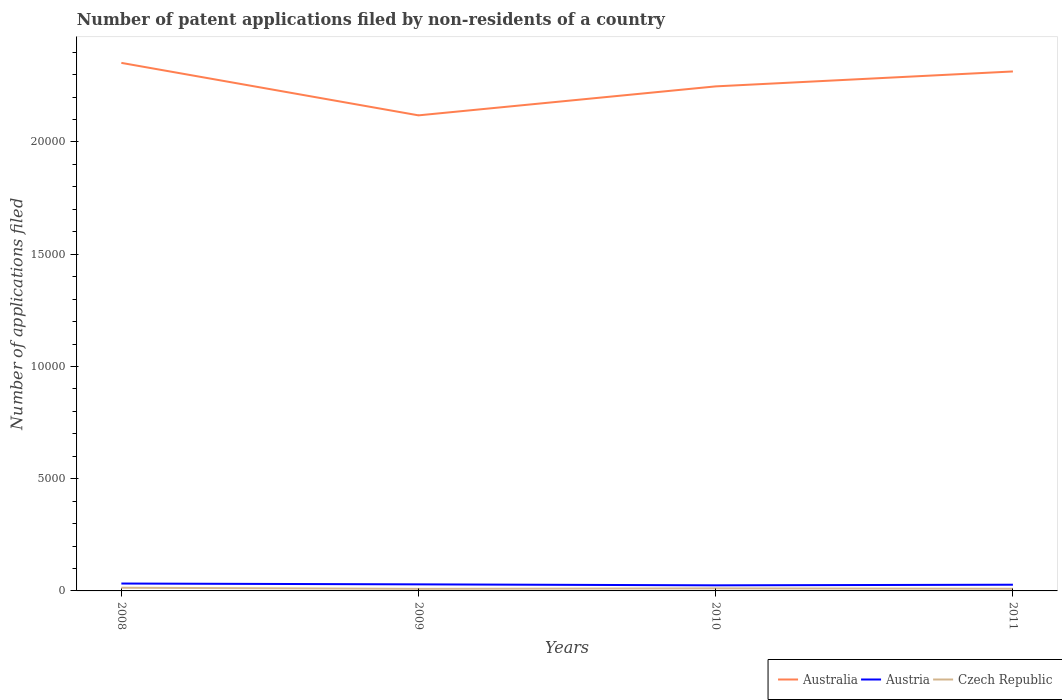How many different coloured lines are there?
Provide a short and direct response. 3. Is the number of lines equal to the number of legend labels?
Ensure brevity in your answer.  Yes. Across all years, what is the maximum number of applications filed in Australia?
Give a very brief answer. 2.12e+04. What is the total number of applications filed in Australia in the graph?
Provide a succinct answer. -665. What is the difference between the highest and the second highest number of applications filed in Czech Republic?
Give a very brief answer. 50. Are the values on the major ticks of Y-axis written in scientific E-notation?
Your answer should be compact. No. Does the graph contain grids?
Give a very brief answer. No. How many legend labels are there?
Keep it short and to the point. 3. What is the title of the graph?
Make the answer very short. Number of patent applications filed by non-residents of a country. Does "Switzerland" appear as one of the legend labels in the graph?
Keep it short and to the point. No. What is the label or title of the X-axis?
Make the answer very short. Years. What is the label or title of the Y-axis?
Provide a succinct answer. Number of applications filed. What is the Number of applications filed of Australia in 2008?
Provide a succinct answer. 2.35e+04. What is the Number of applications filed in Austria in 2008?
Provide a short and direct response. 329. What is the Number of applications filed in Czech Republic in 2008?
Ensure brevity in your answer.  142. What is the Number of applications filed of Australia in 2009?
Give a very brief answer. 2.12e+04. What is the Number of applications filed in Austria in 2009?
Offer a very short reply. 292. What is the Number of applications filed of Czech Republic in 2009?
Give a very brief answer. 92. What is the Number of applications filed of Australia in 2010?
Your answer should be very brief. 2.25e+04. What is the Number of applications filed of Austria in 2010?
Offer a terse response. 249. What is the Number of applications filed of Czech Republic in 2010?
Your answer should be very brief. 114. What is the Number of applications filed of Australia in 2011?
Provide a succinct answer. 2.31e+04. What is the Number of applications filed in Austria in 2011?
Provide a short and direct response. 276. What is the Number of applications filed in Czech Republic in 2011?
Provide a succinct answer. 97. Across all years, what is the maximum Number of applications filed of Australia?
Keep it short and to the point. 2.35e+04. Across all years, what is the maximum Number of applications filed of Austria?
Ensure brevity in your answer.  329. Across all years, what is the maximum Number of applications filed of Czech Republic?
Your response must be concise. 142. Across all years, what is the minimum Number of applications filed of Australia?
Make the answer very short. 2.12e+04. Across all years, what is the minimum Number of applications filed of Austria?
Provide a succinct answer. 249. Across all years, what is the minimum Number of applications filed of Czech Republic?
Ensure brevity in your answer.  92. What is the total Number of applications filed of Australia in the graph?
Keep it short and to the point. 9.03e+04. What is the total Number of applications filed in Austria in the graph?
Keep it short and to the point. 1146. What is the total Number of applications filed of Czech Republic in the graph?
Keep it short and to the point. 445. What is the difference between the Number of applications filed of Australia in 2008 and that in 2009?
Provide a short and direct response. 2338. What is the difference between the Number of applications filed in Austria in 2008 and that in 2009?
Your answer should be compact. 37. What is the difference between the Number of applications filed of Czech Republic in 2008 and that in 2009?
Provide a short and direct response. 50. What is the difference between the Number of applications filed in Australia in 2008 and that in 2010?
Your response must be concise. 1047. What is the difference between the Number of applications filed of Austria in 2008 and that in 2010?
Offer a very short reply. 80. What is the difference between the Number of applications filed of Australia in 2008 and that in 2011?
Your response must be concise. 382. What is the difference between the Number of applications filed of Australia in 2009 and that in 2010?
Keep it short and to the point. -1291. What is the difference between the Number of applications filed in Austria in 2009 and that in 2010?
Your answer should be very brief. 43. What is the difference between the Number of applications filed of Australia in 2009 and that in 2011?
Offer a very short reply. -1956. What is the difference between the Number of applications filed of Austria in 2009 and that in 2011?
Offer a very short reply. 16. What is the difference between the Number of applications filed in Australia in 2010 and that in 2011?
Keep it short and to the point. -665. What is the difference between the Number of applications filed in Australia in 2008 and the Number of applications filed in Austria in 2009?
Provide a short and direct response. 2.32e+04. What is the difference between the Number of applications filed in Australia in 2008 and the Number of applications filed in Czech Republic in 2009?
Offer a very short reply. 2.34e+04. What is the difference between the Number of applications filed in Austria in 2008 and the Number of applications filed in Czech Republic in 2009?
Offer a terse response. 237. What is the difference between the Number of applications filed of Australia in 2008 and the Number of applications filed of Austria in 2010?
Keep it short and to the point. 2.33e+04. What is the difference between the Number of applications filed in Australia in 2008 and the Number of applications filed in Czech Republic in 2010?
Ensure brevity in your answer.  2.34e+04. What is the difference between the Number of applications filed in Austria in 2008 and the Number of applications filed in Czech Republic in 2010?
Provide a short and direct response. 215. What is the difference between the Number of applications filed in Australia in 2008 and the Number of applications filed in Austria in 2011?
Offer a very short reply. 2.32e+04. What is the difference between the Number of applications filed in Australia in 2008 and the Number of applications filed in Czech Republic in 2011?
Offer a terse response. 2.34e+04. What is the difference between the Number of applications filed of Austria in 2008 and the Number of applications filed of Czech Republic in 2011?
Provide a succinct answer. 232. What is the difference between the Number of applications filed in Australia in 2009 and the Number of applications filed in Austria in 2010?
Your answer should be compact. 2.09e+04. What is the difference between the Number of applications filed in Australia in 2009 and the Number of applications filed in Czech Republic in 2010?
Ensure brevity in your answer.  2.11e+04. What is the difference between the Number of applications filed in Austria in 2009 and the Number of applications filed in Czech Republic in 2010?
Provide a short and direct response. 178. What is the difference between the Number of applications filed of Australia in 2009 and the Number of applications filed of Austria in 2011?
Your answer should be compact. 2.09e+04. What is the difference between the Number of applications filed in Australia in 2009 and the Number of applications filed in Czech Republic in 2011?
Ensure brevity in your answer.  2.11e+04. What is the difference between the Number of applications filed of Austria in 2009 and the Number of applications filed of Czech Republic in 2011?
Make the answer very short. 195. What is the difference between the Number of applications filed in Australia in 2010 and the Number of applications filed in Austria in 2011?
Make the answer very short. 2.22e+04. What is the difference between the Number of applications filed in Australia in 2010 and the Number of applications filed in Czech Republic in 2011?
Give a very brief answer. 2.24e+04. What is the difference between the Number of applications filed of Austria in 2010 and the Number of applications filed of Czech Republic in 2011?
Offer a terse response. 152. What is the average Number of applications filed of Australia per year?
Keep it short and to the point. 2.26e+04. What is the average Number of applications filed in Austria per year?
Offer a terse response. 286.5. What is the average Number of applications filed in Czech Republic per year?
Make the answer very short. 111.25. In the year 2008, what is the difference between the Number of applications filed in Australia and Number of applications filed in Austria?
Make the answer very short. 2.32e+04. In the year 2008, what is the difference between the Number of applications filed of Australia and Number of applications filed of Czech Republic?
Offer a very short reply. 2.34e+04. In the year 2008, what is the difference between the Number of applications filed in Austria and Number of applications filed in Czech Republic?
Provide a short and direct response. 187. In the year 2009, what is the difference between the Number of applications filed of Australia and Number of applications filed of Austria?
Offer a very short reply. 2.09e+04. In the year 2009, what is the difference between the Number of applications filed in Australia and Number of applications filed in Czech Republic?
Your answer should be very brief. 2.11e+04. In the year 2009, what is the difference between the Number of applications filed of Austria and Number of applications filed of Czech Republic?
Make the answer very short. 200. In the year 2010, what is the difference between the Number of applications filed of Australia and Number of applications filed of Austria?
Offer a very short reply. 2.22e+04. In the year 2010, what is the difference between the Number of applications filed of Australia and Number of applications filed of Czech Republic?
Provide a short and direct response. 2.24e+04. In the year 2010, what is the difference between the Number of applications filed of Austria and Number of applications filed of Czech Republic?
Offer a terse response. 135. In the year 2011, what is the difference between the Number of applications filed of Australia and Number of applications filed of Austria?
Make the answer very short. 2.29e+04. In the year 2011, what is the difference between the Number of applications filed of Australia and Number of applications filed of Czech Republic?
Your answer should be compact. 2.30e+04. In the year 2011, what is the difference between the Number of applications filed of Austria and Number of applications filed of Czech Republic?
Offer a very short reply. 179. What is the ratio of the Number of applications filed of Australia in 2008 to that in 2009?
Make the answer very short. 1.11. What is the ratio of the Number of applications filed of Austria in 2008 to that in 2009?
Provide a succinct answer. 1.13. What is the ratio of the Number of applications filed in Czech Republic in 2008 to that in 2009?
Ensure brevity in your answer.  1.54. What is the ratio of the Number of applications filed in Australia in 2008 to that in 2010?
Ensure brevity in your answer.  1.05. What is the ratio of the Number of applications filed of Austria in 2008 to that in 2010?
Provide a succinct answer. 1.32. What is the ratio of the Number of applications filed of Czech Republic in 2008 to that in 2010?
Give a very brief answer. 1.25. What is the ratio of the Number of applications filed in Australia in 2008 to that in 2011?
Provide a short and direct response. 1.02. What is the ratio of the Number of applications filed in Austria in 2008 to that in 2011?
Provide a succinct answer. 1.19. What is the ratio of the Number of applications filed in Czech Republic in 2008 to that in 2011?
Give a very brief answer. 1.46. What is the ratio of the Number of applications filed of Australia in 2009 to that in 2010?
Offer a terse response. 0.94. What is the ratio of the Number of applications filed in Austria in 2009 to that in 2010?
Offer a very short reply. 1.17. What is the ratio of the Number of applications filed in Czech Republic in 2009 to that in 2010?
Offer a terse response. 0.81. What is the ratio of the Number of applications filed of Australia in 2009 to that in 2011?
Ensure brevity in your answer.  0.92. What is the ratio of the Number of applications filed in Austria in 2009 to that in 2011?
Offer a very short reply. 1.06. What is the ratio of the Number of applications filed of Czech Republic in 2009 to that in 2011?
Make the answer very short. 0.95. What is the ratio of the Number of applications filed of Australia in 2010 to that in 2011?
Your response must be concise. 0.97. What is the ratio of the Number of applications filed of Austria in 2010 to that in 2011?
Ensure brevity in your answer.  0.9. What is the ratio of the Number of applications filed in Czech Republic in 2010 to that in 2011?
Make the answer very short. 1.18. What is the difference between the highest and the second highest Number of applications filed of Australia?
Keep it short and to the point. 382. What is the difference between the highest and the second highest Number of applications filed of Austria?
Keep it short and to the point. 37. What is the difference between the highest and the second highest Number of applications filed of Czech Republic?
Your response must be concise. 28. What is the difference between the highest and the lowest Number of applications filed of Australia?
Your answer should be compact. 2338. 